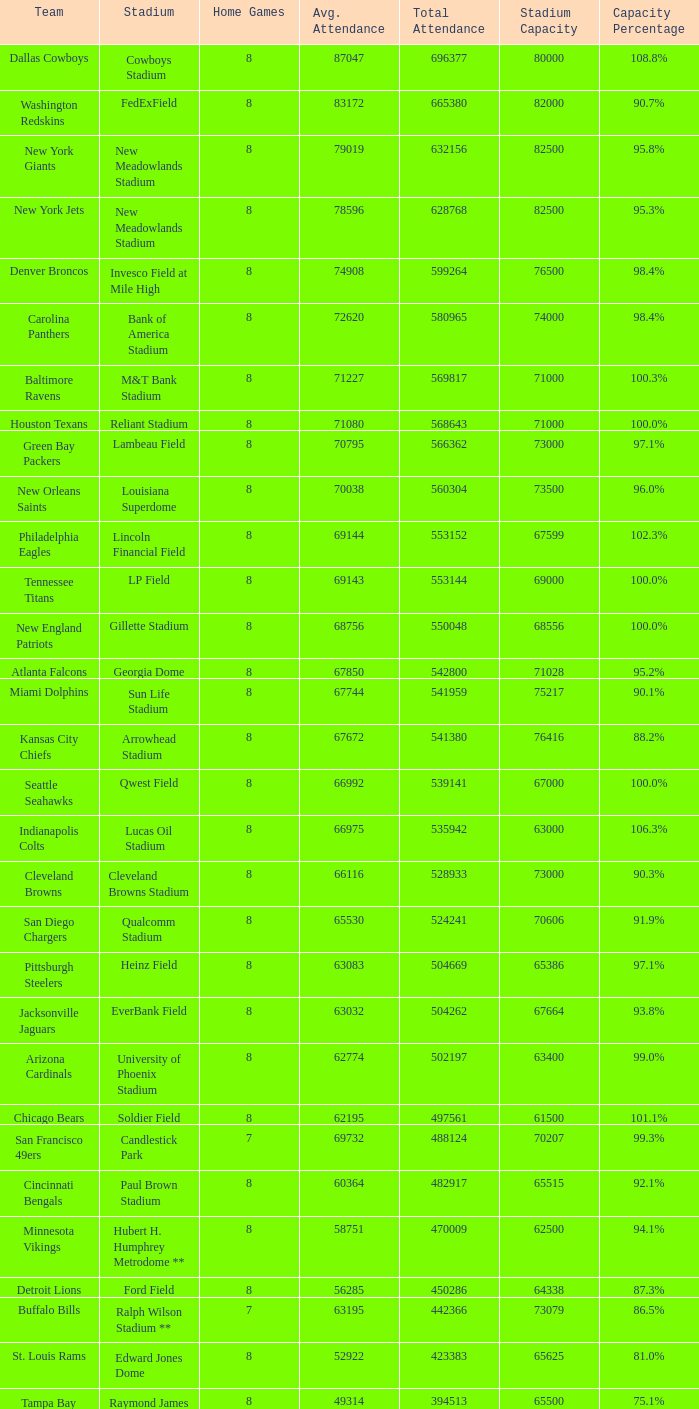Could you parse the entire table? {'header': ['Team', 'Stadium', 'Home Games', 'Avg. Attendance', 'Total Attendance', 'Stadium Capacity', 'Capacity Percentage'], 'rows': [['Dallas Cowboys', 'Cowboys Stadium', '8', '87047', '696377', '80000', '108.8%'], ['Washington Redskins', 'FedExField', '8', '83172', '665380', '82000', '90.7%'], ['New York Giants', 'New Meadowlands Stadium', '8', '79019', '632156', '82500', '95.8%'], ['New York Jets', 'New Meadowlands Stadium', '8', '78596', '628768', '82500', '95.3%'], ['Denver Broncos', 'Invesco Field at Mile High', '8', '74908', '599264', '76500', '98.4%'], ['Carolina Panthers', 'Bank of America Stadium', '8', '72620', '580965', '74000', '98.4%'], ['Baltimore Ravens', 'M&T Bank Stadium', '8', '71227', '569817', '71000', '100.3%'], ['Houston Texans', 'Reliant Stadium', '8', '71080', '568643', '71000', '100.0%'], ['Green Bay Packers', 'Lambeau Field', '8', '70795', '566362', '73000', '97.1%'], ['New Orleans Saints', 'Louisiana Superdome', '8', '70038', '560304', '73500', '96.0%'], ['Philadelphia Eagles', 'Lincoln Financial Field', '8', '69144', '553152', '67599', '102.3%'], ['Tennessee Titans', 'LP Field', '8', '69143', '553144', '69000', '100.0%'], ['New England Patriots', 'Gillette Stadium', '8', '68756', '550048', '68556', '100.0%'], ['Atlanta Falcons', 'Georgia Dome', '8', '67850', '542800', '71028', '95.2%'], ['Miami Dolphins', 'Sun Life Stadium', '8', '67744', '541959', '75217', '90.1%'], ['Kansas City Chiefs', 'Arrowhead Stadium', '8', '67672', '541380', '76416', '88.2%'], ['Seattle Seahawks', 'Qwest Field', '8', '66992', '539141', '67000', '100.0%'], ['Indianapolis Colts', 'Lucas Oil Stadium', '8', '66975', '535942', '63000', '106.3%'], ['Cleveland Browns', 'Cleveland Browns Stadium', '8', '66116', '528933', '73000', '90.3%'], ['San Diego Chargers', 'Qualcomm Stadium', '8', '65530', '524241', '70606', '91.9%'], ['Pittsburgh Steelers', 'Heinz Field', '8', '63083', '504669', '65386', '97.1%'], ['Jacksonville Jaguars', 'EverBank Field', '8', '63032', '504262', '67664', '93.8%'], ['Arizona Cardinals', 'University of Phoenix Stadium', '8', '62774', '502197', '63400', '99.0%'], ['Chicago Bears', 'Soldier Field', '8', '62195', '497561', '61500', '101.1%'], ['San Francisco 49ers', 'Candlestick Park', '7', '69732', '488124', '70207', '99.3%'], ['Cincinnati Bengals', 'Paul Brown Stadium', '8', '60364', '482917', '65515', '92.1%'], ['Minnesota Vikings', 'Hubert H. Humphrey Metrodome **', '8', '58751', '470009', '62500', '94.1%'], ['Detroit Lions', 'Ford Field', '8', '56285', '450286', '64338', '87.3%'], ['Buffalo Bills', 'Ralph Wilson Stadium **', '7', '63195', '442366', '73079', '86.5%'], ['St. Louis Rams', 'Edward Jones Dome', '8', '52922', '423383', '65625', '81.0%'], ['Tampa Bay Buccaneers', 'Raymond James Stadium', '8', '49314', '394513', '65500', '75.1%']]} What was the typical attendance when the combined attendance was 541380? 67672.0. 